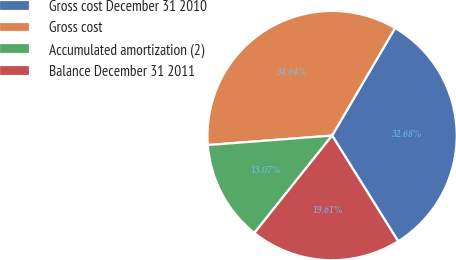<chart> <loc_0><loc_0><loc_500><loc_500><pie_chart><fcel>Gross cost December 31 2010<fcel>Gross cost<fcel>Accumulated amortization (2)<fcel>Balance December 31 2011<nl><fcel>32.68%<fcel>34.64%<fcel>13.07%<fcel>19.61%<nl></chart> 